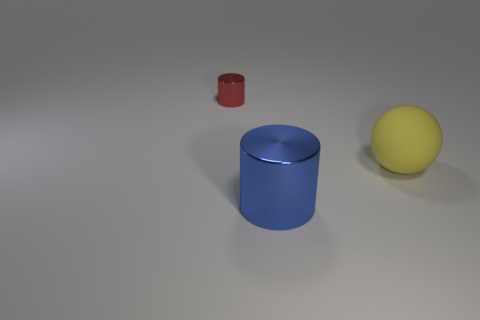There is a large matte object; is it the same color as the shiny object that is to the left of the large blue metallic object?
Your answer should be very brief. No. Is there another yellow rubber ball that has the same size as the rubber sphere?
Offer a terse response. No. There is a cylinder that is behind the large metallic object; what is its size?
Your response must be concise. Small. There is a metallic cylinder that is behind the large cylinder; is there a big blue object that is behind it?
Make the answer very short. No. How many other things are there of the same shape as the big yellow rubber object?
Your answer should be very brief. 0. Is the small metal object the same shape as the yellow thing?
Make the answer very short. No. What is the color of the object that is both to the left of the yellow matte ball and behind the blue shiny cylinder?
Your answer should be compact. Red. What number of big objects are either balls or brown rubber cylinders?
Your response must be concise. 1. Is there anything else of the same color as the big shiny cylinder?
Offer a terse response. No. What is the material of the object right of the large object that is in front of the ball that is in front of the red shiny object?
Offer a very short reply. Rubber. 